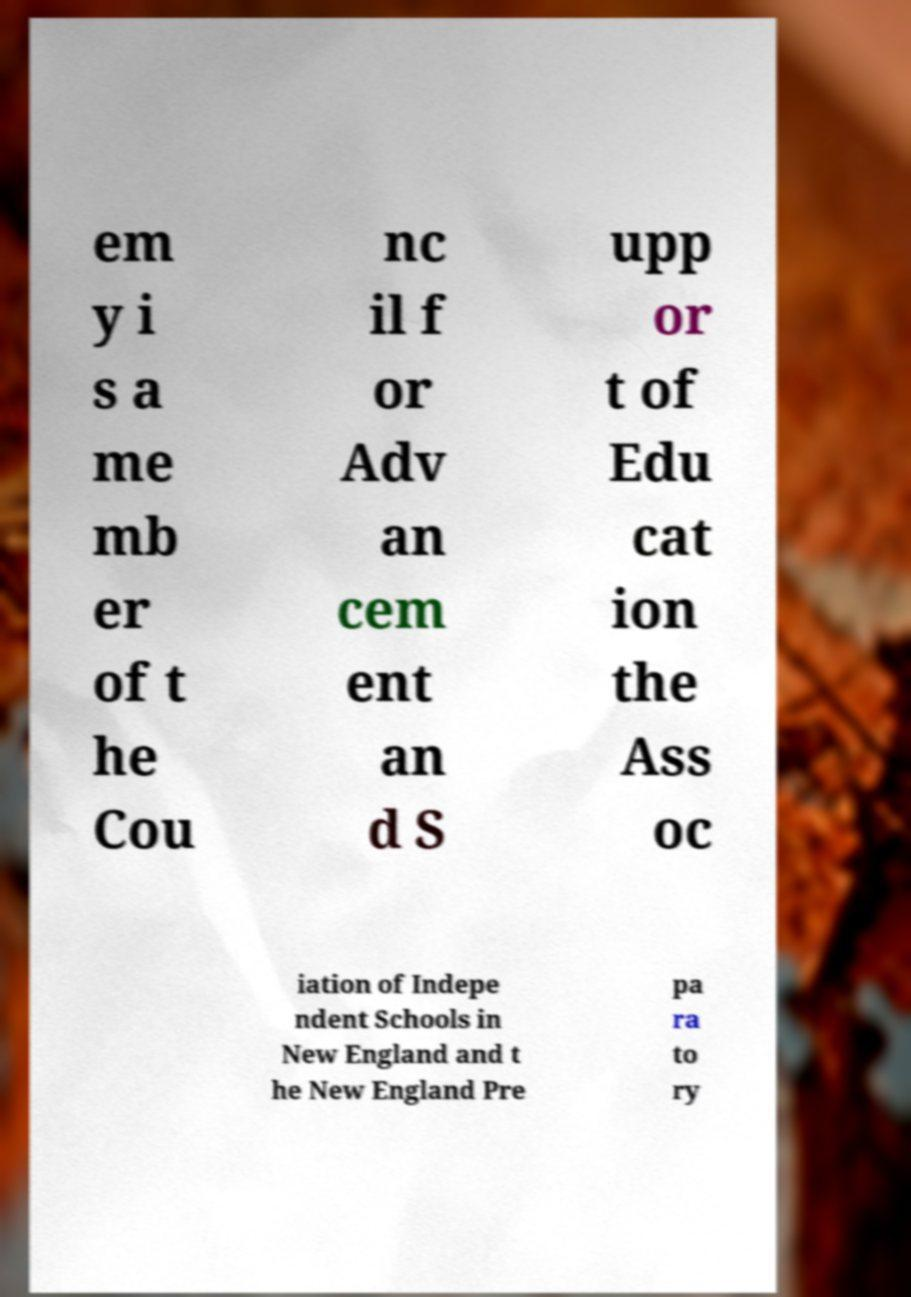There's text embedded in this image that I need extracted. Can you transcribe it verbatim? em y i s a me mb er of t he Cou nc il f or Adv an cem ent an d S upp or t of Edu cat ion the Ass oc iation of Indepe ndent Schools in New England and t he New England Pre pa ra to ry 